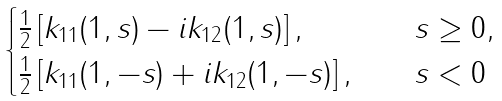Convert formula to latex. <formula><loc_0><loc_0><loc_500><loc_500>\begin{cases} \frac { 1 } { 2 } \left [ k _ { 1 1 } ( 1 , s ) - i k _ { 1 2 } ( 1 , s ) \right ] , & \quad s \geq 0 , \\ \frac { 1 } { 2 } \left [ k _ { 1 1 } ( 1 , - s ) + i k _ { 1 2 } ( 1 , - s ) \right ] , & \quad s < 0 \end{cases}</formula> 